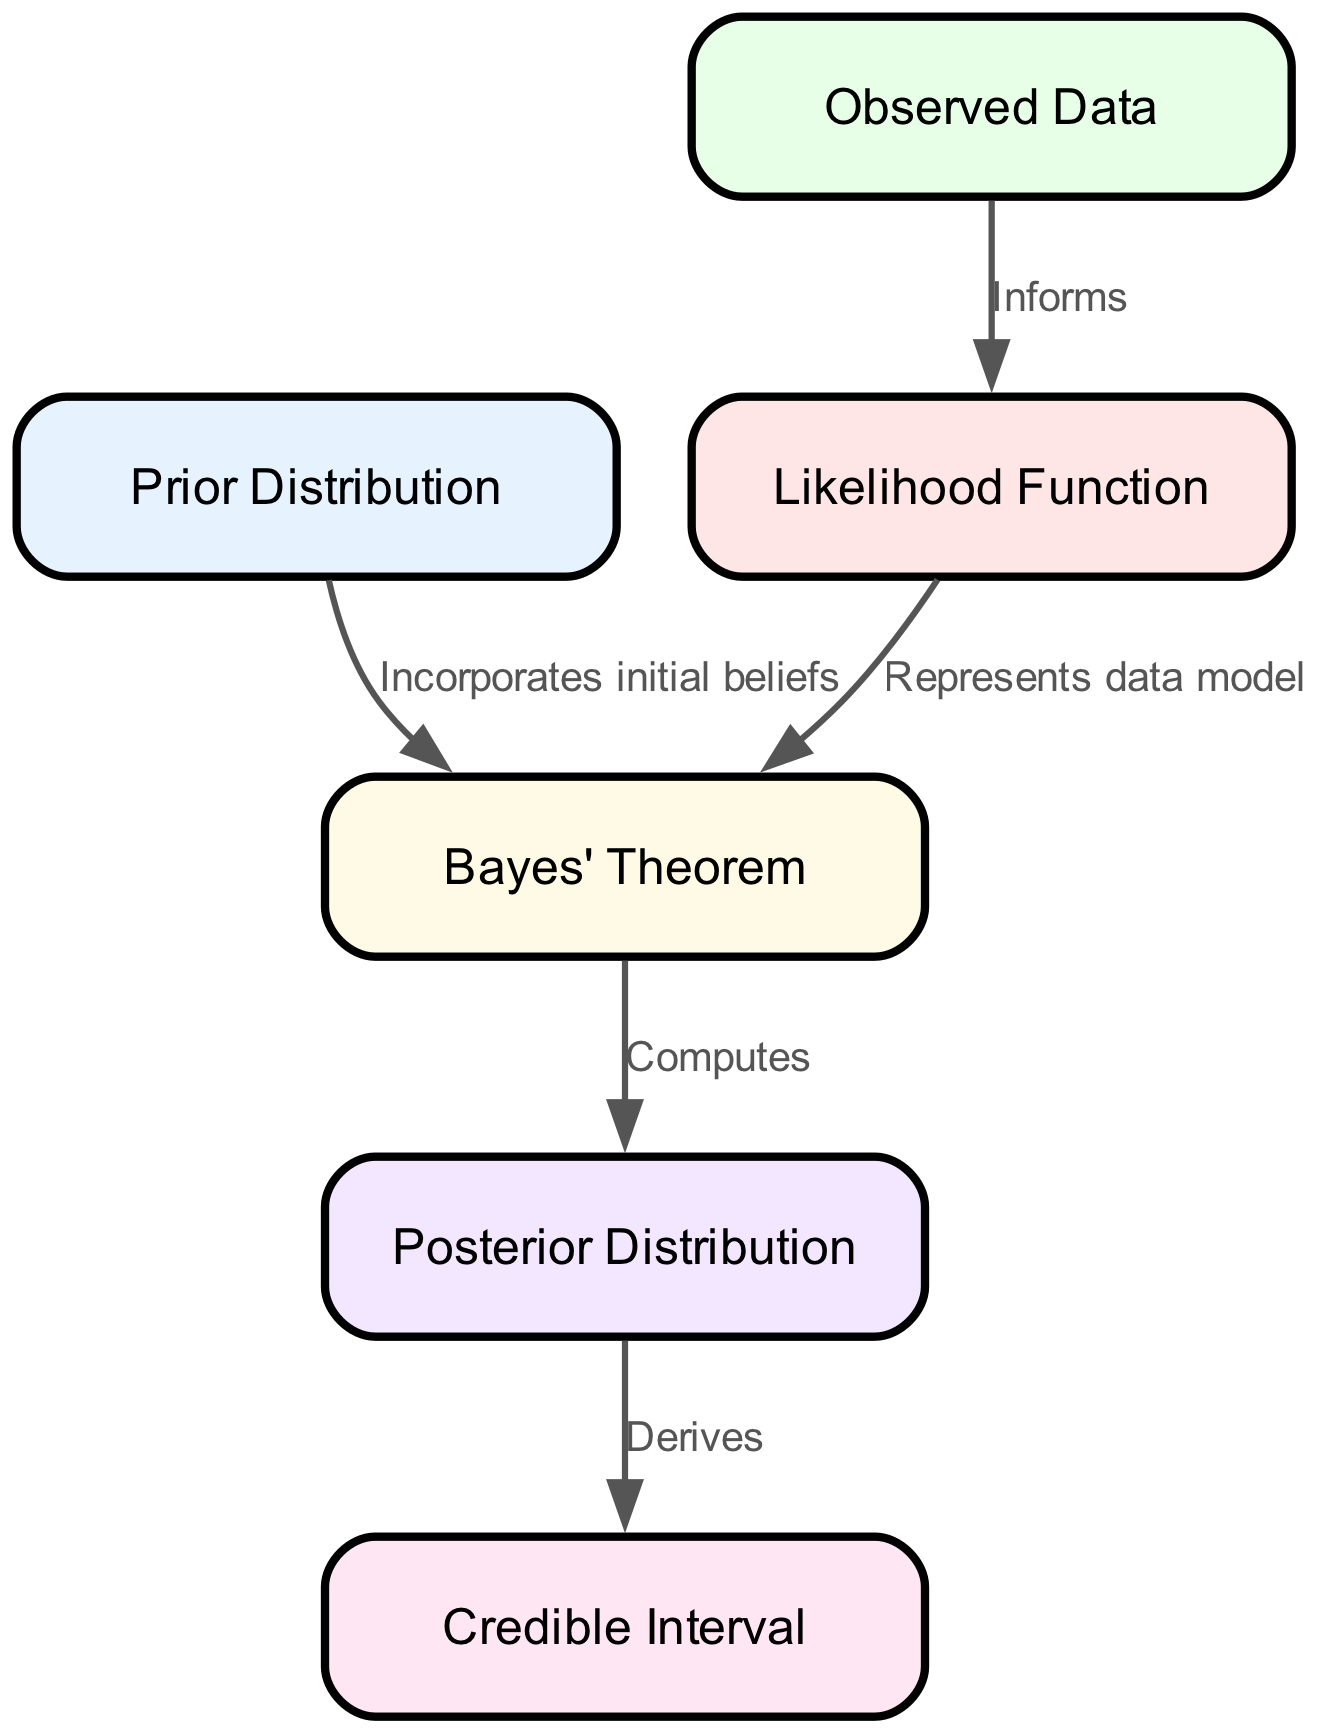What is the total number of nodes in the diagram? The diagram consists of six defined nodes, which are: Prior Distribution, Likelihood Function, Observed Data, Bayes' Theorem, Posterior Distribution, and Credible Interval. By counting these nodes, we establish the total as six.
Answer: 6 What connects the Prior Distribution to Bayes' Theorem? The edge between Prior Distribution and Bayes' Theorem indicates that it "Incorporates initial beliefs," showing the relationship that the prior distribution feeds into Bayes' Theorem.
Answer: Incorporates initial beliefs What is derived from the Posterior Distribution? According to the edge from Posterior Distribution to Credible Interval, we see that the posterior leads to the calculation of the credible interval, indicating it is a result derived from the posterior.
Answer: Credible Interval What role does Observed Data play in relation to Likelihood Function? The relationship is established by the edge that states Observed Data "Informs" the Likelihood Function, indicating that the observed data serves as input or information for models represented by likelihood functions.
Answer: Informs How many edges are present in the diagram? By examining the connections between nodes, we can count a total of five directed edges that represent the relationships and flow between the components of the Bayesian inference process.
Answer: 5 What does the edge from Likelihood Function to Bayes' Theorem indicate? The edge defines that the Likelihood Function "Represents data model," meaning that likelihood functions model the data and are essential for applying Bayes' Theorem in this context.
Answer: Represents data model What is the final output of the Bayesian process depicted in the diagram? The final output, as indicated by the flow from Bayes' Theorem, relates to the Posterior Distribution, signifying that this is the outcome of the Bayesian inference process.
Answer: Posterior Distribution 